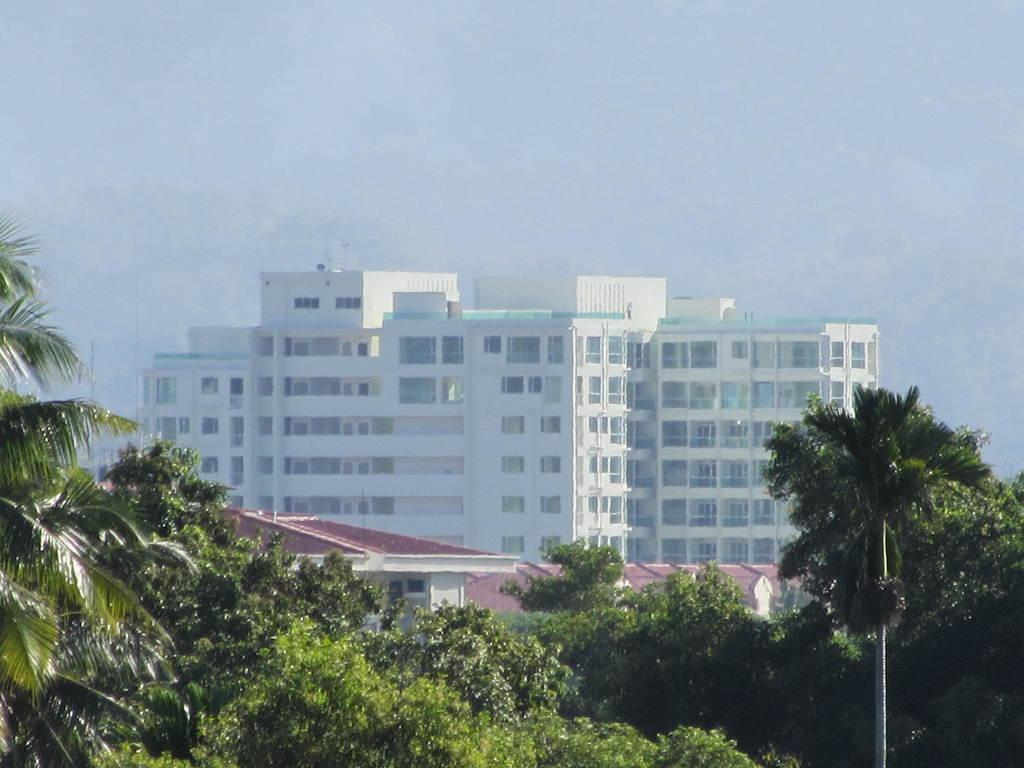What type of natural elements can be seen in the image? There are trees in the image. What type of man-made structures are present in the image? There are buildings in the image. What is visible at the top of the image? The sky is visible at the top of the image. What color is the family's sweater in the image? There is no family or sweater present in the image; it features trees and buildings. 